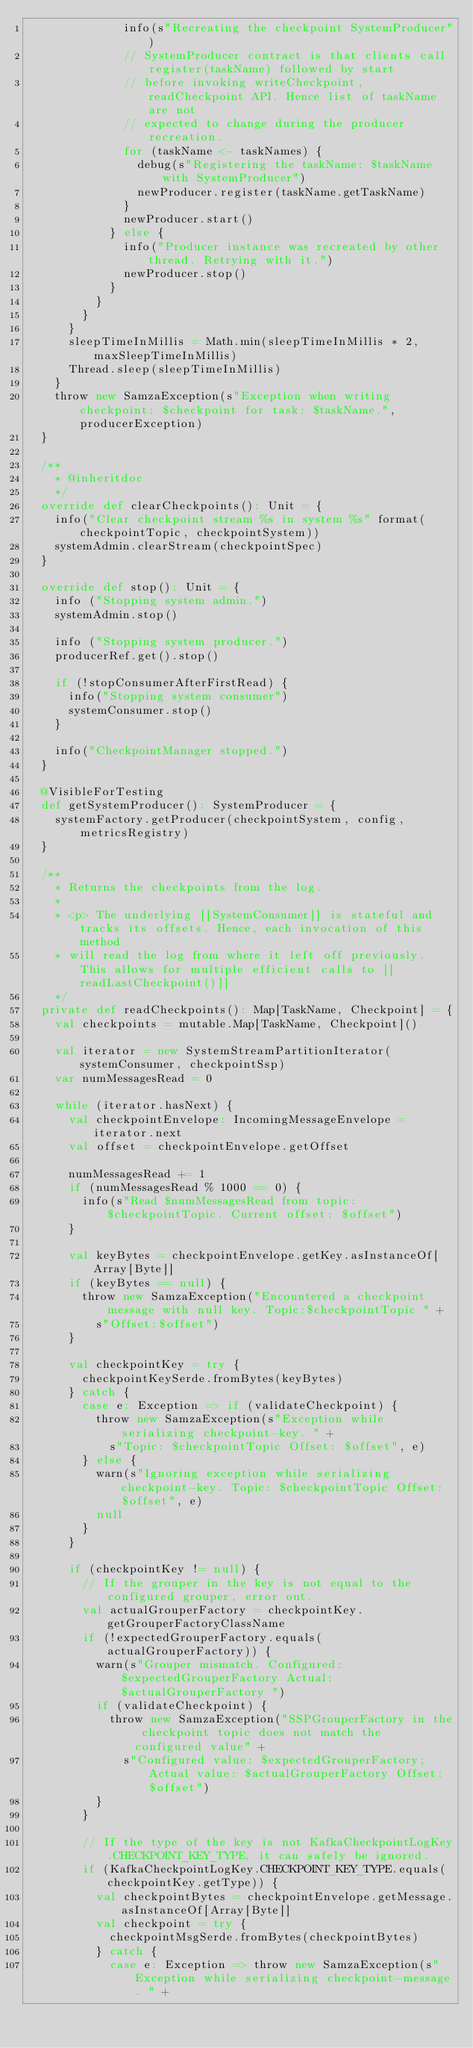Convert code to text. <code><loc_0><loc_0><loc_500><loc_500><_Scala_>              info(s"Recreating the checkpoint SystemProducer")
              // SystemProducer contract is that clients call register(taskName) followed by start
              // before invoking writeCheckpoint, readCheckpoint API. Hence list of taskName are not
              // expected to change during the producer recreation.
              for (taskName <- taskNames) {
                debug(s"Registering the taskName: $taskName with SystemProducer")
                newProducer.register(taskName.getTaskName)
              }
              newProducer.start()
            } else {
              info("Producer instance was recreated by other thread. Retrying with it.")
              newProducer.stop()
            }
          }
        }
      }
      sleepTimeInMillis = Math.min(sleepTimeInMillis * 2, maxSleepTimeInMillis)
      Thread.sleep(sleepTimeInMillis)
    }
    throw new SamzaException(s"Exception when writing checkpoint: $checkpoint for task: $taskName.", producerException)
  }

  /**
    * @inheritdoc
    */
  override def clearCheckpoints(): Unit = {
    info("Clear checkpoint stream %s in system %s" format(checkpointTopic, checkpointSystem))
    systemAdmin.clearStream(checkpointSpec)
  }

  override def stop(): Unit = {
    info ("Stopping system admin.")
    systemAdmin.stop()

    info ("Stopping system producer.")
    producerRef.get().stop()

    if (!stopConsumerAfterFirstRead) {
      info("Stopping system consumer")
      systemConsumer.stop()
    }

    info("CheckpointManager stopped.")
  }

  @VisibleForTesting
  def getSystemProducer(): SystemProducer = {
    systemFactory.getProducer(checkpointSystem, config, metricsRegistry)
  }

  /**
    * Returns the checkpoints from the log.
    *
    * <p> The underlying [[SystemConsumer]] is stateful and tracks its offsets. Hence, each invocation of this method
    * will read the log from where it left off previously. This allows for multiple efficient calls to [[readLastCheckpoint()]]
    */
  private def readCheckpoints(): Map[TaskName, Checkpoint] = {
    val checkpoints = mutable.Map[TaskName, Checkpoint]()

    val iterator = new SystemStreamPartitionIterator(systemConsumer, checkpointSsp)
    var numMessagesRead = 0

    while (iterator.hasNext) {
      val checkpointEnvelope: IncomingMessageEnvelope = iterator.next
      val offset = checkpointEnvelope.getOffset

      numMessagesRead += 1
      if (numMessagesRead % 1000 == 0) {
        info(s"Read $numMessagesRead from topic: $checkpointTopic. Current offset: $offset")
      }

      val keyBytes = checkpointEnvelope.getKey.asInstanceOf[Array[Byte]]
      if (keyBytes == null) {
        throw new SamzaException("Encountered a checkpoint message with null key. Topic:$checkpointTopic " +
          s"Offset:$offset")
      }

      val checkpointKey = try {
        checkpointKeySerde.fromBytes(keyBytes)
      } catch {
        case e: Exception => if (validateCheckpoint) {
          throw new SamzaException(s"Exception while serializing checkpoint-key. " +
            s"Topic: $checkpointTopic Offset: $offset", e)
        } else {
          warn(s"Ignoring exception while serializing checkpoint-key. Topic: $checkpointTopic Offset: $offset", e)
          null
        }
      }

      if (checkpointKey != null) {
        // If the grouper in the key is not equal to the configured grouper, error out.
        val actualGrouperFactory = checkpointKey.getGrouperFactoryClassName
        if (!expectedGrouperFactory.equals(actualGrouperFactory)) {
          warn(s"Grouper mismatch. Configured: $expectedGrouperFactory Actual: $actualGrouperFactory ")
          if (validateCheckpoint) {
            throw new SamzaException("SSPGrouperFactory in the checkpoint topic does not match the configured value" +
              s"Configured value: $expectedGrouperFactory; Actual value: $actualGrouperFactory Offset: $offset")
          }
        }

        // If the type of the key is not KafkaCheckpointLogKey.CHECKPOINT_KEY_TYPE, it can safely be ignored.
        if (KafkaCheckpointLogKey.CHECKPOINT_KEY_TYPE.equals(checkpointKey.getType)) {
          val checkpointBytes = checkpointEnvelope.getMessage.asInstanceOf[Array[Byte]]
          val checkpoint = try {
            checkpointMsgSerde.fromBytes(checkpointBytes)
          } catch {
            case e: Exception => throw new SamzaException(s"Exception while serializing checkpoint-message. " +</code> 